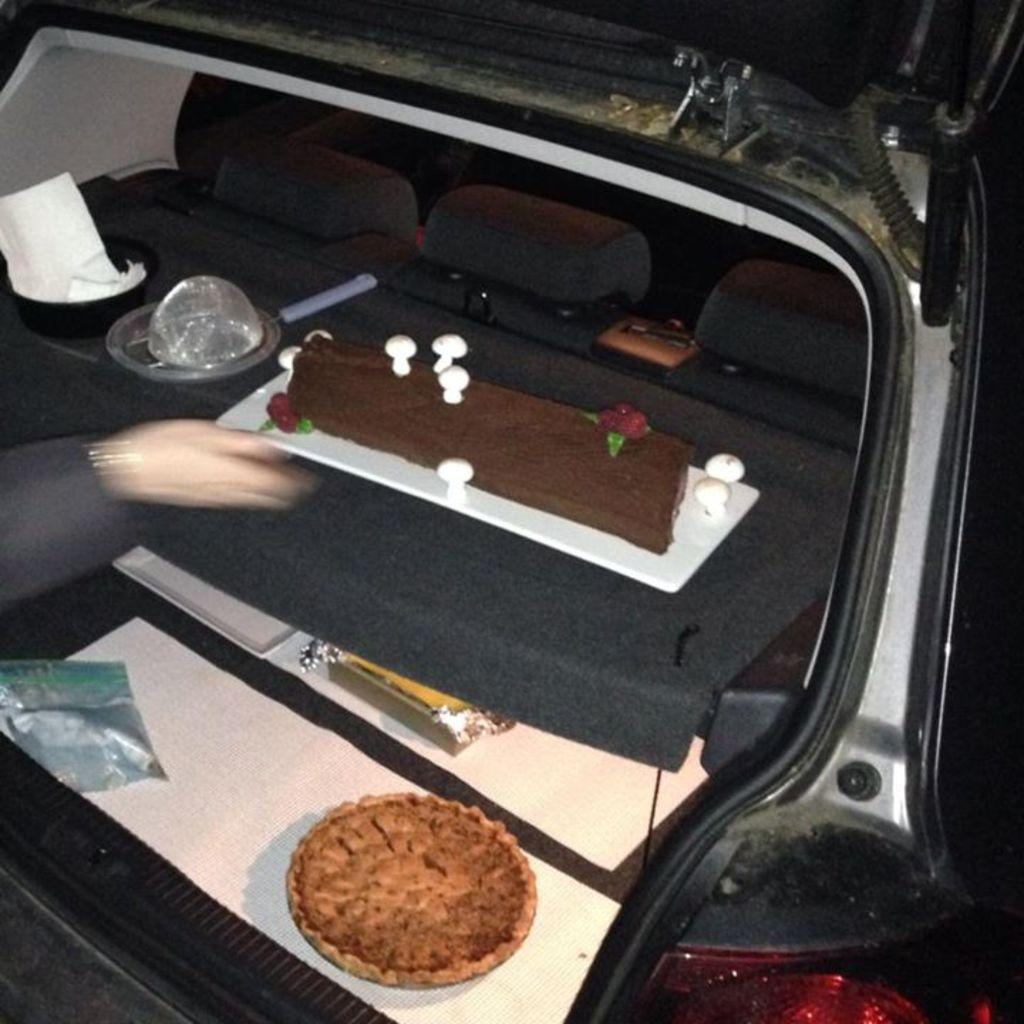What type of items can be seen in the image? There are food items in the image. What else can be found in the image besides food items? There are objects in the vehicle and seats in the image. Can you describe any part of a person in the image? A person's hand is visible in the image. What is one feature of the vehicle in the image? There is a headlight in the image. What type of whistle can be heard in the image? There is no whistle present in the image, and therefore no sound can be heard. Can you describe the rake that is being used in the image? There is no rake present in the image; it is not a tool or object that can be found in the scene. 